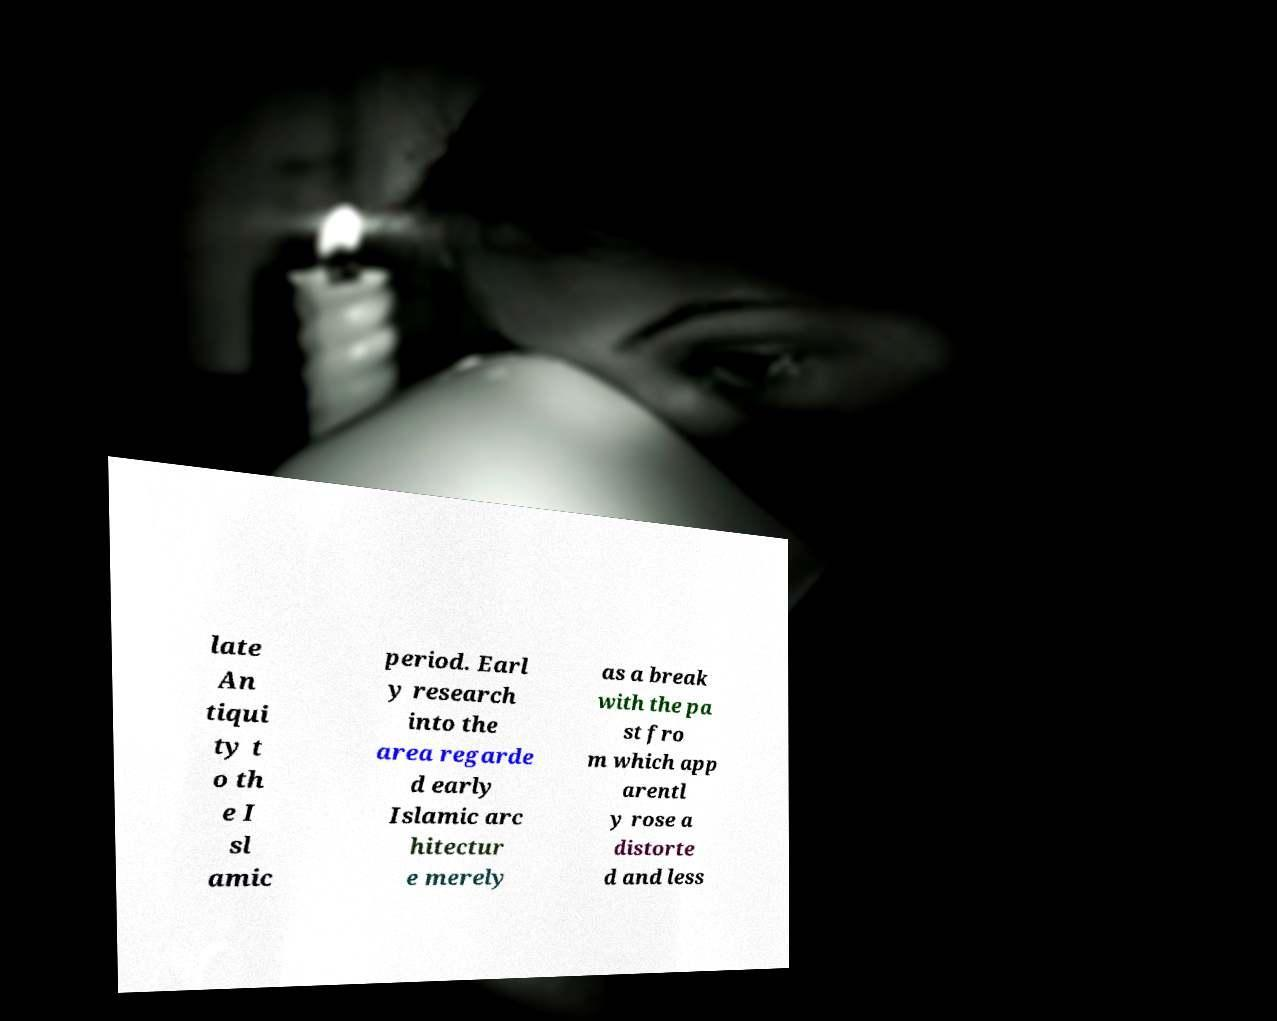Please read and relay the text visible in this image. What does it say? late An tiqui ty t o th e I sl amic period. Earl y research into the area regarde d early Islamic arc hitectur e merely as a break with the pa st fro m which app arentl y rose a distorte d and less 